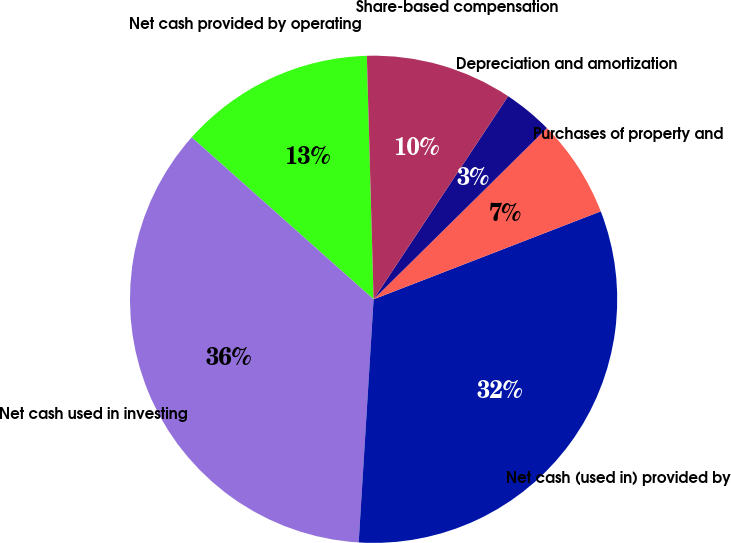Convert chart to OTSL. <chart><loc_0><loc_0><loc_500><loc_500><pie_chart><fcel>Net cash provided by operating<fcel>Net cash used in investing<fcel>Net cash (used in) provided by<fcel>Purchases of property and<fcel>Depreciation and amortization<fcel>Share-based compensation<nl><fcel>12.98%<fcel>35.6%<fcel>31.85%<fcel>6.52%<fcel>3.29%<fcel>9.75%<nl></chart> 